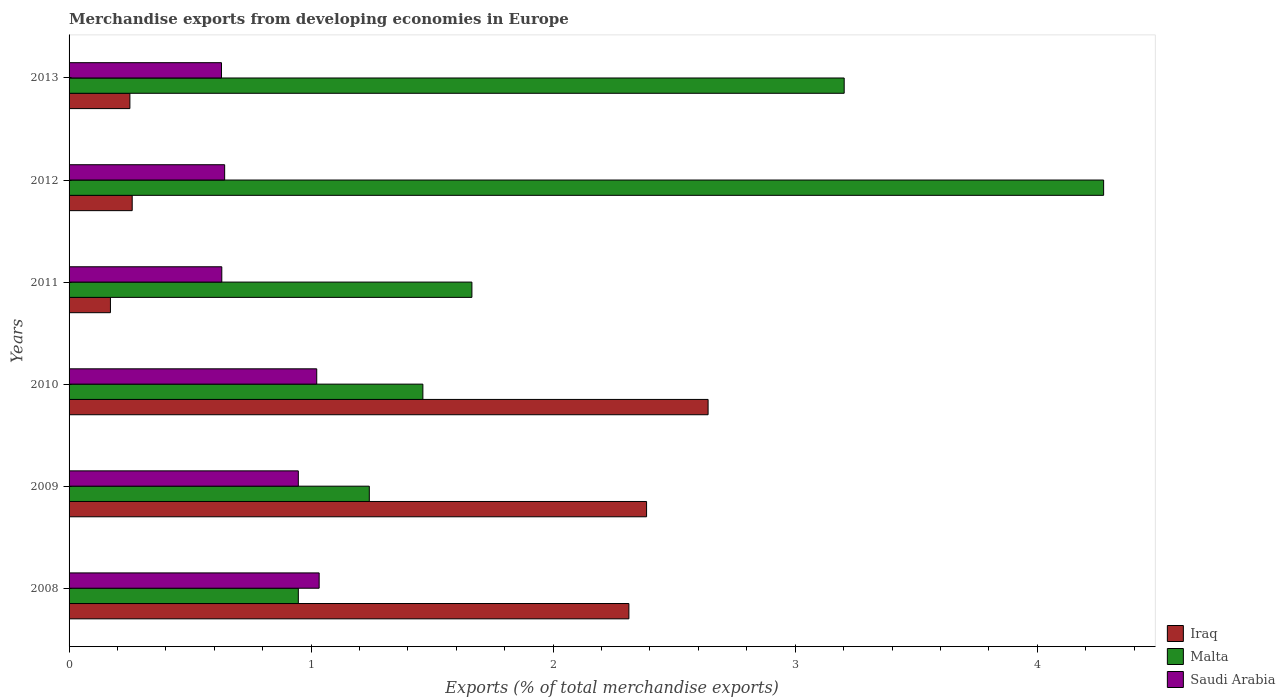How many bars are there on the 2nd tick from the top?
Offer a very short reply. 3. What is the percentage of total merchandise exports in Saudi Arabia in 2010?
Give a very brief answer. 1.02. Across all years, what is the maximum percentage of total merchandise exports in Saudi Arabia?
Your answer should be very brief. 1.03. Across all years, what is the minimum percentage of total merchandise exports in Malta?
Provide a short and direct response. 0.95. In which year was the percentage of total merchandise exports in Malta minimum?
Offer a very short reply. 2008. What is the total percentage of total merchandise exports in Iraq in the graph?
Ensure brevity in your answer.  8.02. What is the difference between the percentage of total merchandise exports in Saudi Arabia in 2010 and that in 2011?
Offer a very short reply. 0.39. What is the difference between the percentage of total merchandise exports in Saudi Arabia in 2010 and the percentage of total merchandise exports in Malta in 2009?
Your answer should be very brief. -0.22. What is the average percentage of total merchandise exports in Iraq per year?
Provide a short and direct response. 1.34. In the year 2009, what is the difference between the percentage of total merchandise exports in Saudi Arabia and percentage of total merchandise exports in Malta?
Ensure brevity in your answer.  -0.29. What is the ratio of the percentage of total merchandise exports in Malta in 2009 to that in 2012?
Give a very brief answer. 0.29. Is the percentage of total merchandise exports in Malta in 2008 less than that in 2011?
Keep it short and to the point. Yes. What is the difference between the highest and the second highest percentage of total merchandise exports in Malta?
Your answer should be very brief. 1.07. What is the difference between the highest and the lowest percentage of total merchandise exports in Saudi Arabia?
Ensure brevity in your answer.  0.4. Is the sum of the percentage of total merchandise exports in Malta in 2009 and 2012 greater than the maximum percentage of total merchandise exports in Saudi Arabia across all years?
Your response must be concise. Yes. What does the 2nd bar from the top in 2009 represents?
Give a very brief answer. Malta. What does the 2nd bar from the bottom in 2011 represents?
Offer a very short reply. Malta. What is the difference between two consecutive major ticks on the X-axis?
Give a very brief answer. 1. Are the values on the major ticks of X-axis written in scientific E-notation?
Offer a terse response. No. Where does the legend appear in the graph?
Offer a terse response. Bottom right. How many legend labels are there?
Keep it short and to the point. 3. What is the title of the graph?
Provide a succinct answer. Merchandise exports from developing economies in Europe. Does "Tonga" appear as one of the legend labels in the graph?
Make the answer very short. No. What is the label or title of the X-axis?
Ensure brevity in your answer.  Exports (% of total merchandise exports). What is the Exports (% of total merchandise exports) of Iraq in 2008?
Offer a terse response. 2.31. What is the Exports (% of total merchandise exports) of Malta in 2008?
Your answer should be very brief. 0.95. What is the Exports (% of total merchandise exports) in Saudi Arabia in 2008?
Your response must be concise. 1.03. What is the Exports (% of total merchandise exports) in Iraq in 2009?
Offer a very short reply. 2.39. What is the Exports (% of total merchandise exports) of Malta in 2009?
Make the answer very short. 1.24. What is the Exports (% of total merchandise exports) in Saudi Arabia in 2009?
Make the answer very short. 0.95. What is the Exports (% of total merchandise exports) of Iraq in 2010?
Provide a short and direct response. 2.64. What is the Exports (% of total merchandise exports) of Malta in 2010?
Offer a terse response. 1.46. What is the Exports (% of total merchandise exports) of Saudi Arabia in 2010?
Your answer should be compact. 1.02. What is the Exports (% of total merchandise exports) of Iraq in 2011?
Give a very brief answer. 0.17. What is the Exports (% of total merchandise exports) of Malta in 2011?
Provide a short and direct response. 1.66. What is the Exports (% of total merchandise exports) in Saudi Arabia in 2011?
Your answer should be very brief. 0.63. What is the Exports (% of total merchandise exports) of Iraq in 2012?
Provide a succinct answer. 0.26. What is the Exports (% of total merchandise exports) of Malta in 2012?
Ensure brevity in your answer.  4.27. What is the Exports (% of total merchandise exports) in Saudi Arabia in 2012?
Keep it short and to the point. 0.64. What is the Exports (% of total merchandise exports) of Iraq in 2013?
Ensure brevity in your answer.  0.25. What is the Exports (% of total merchandise exports) in Malta in 2013?
Keep it short and to the point. 3.2. What is the Exports (% of total merchandise exports) in Saudi Arabia in 2013?
Keep it short and to the point. 0.63. Across all years, what is the maximum Exports (% of total merchandise exports) of Iraq?
Your answer should be very brief. 2.64. Across all years, what is the maximum Exports (% of total merchandise exports) in Malta?
Offer a terse response. 4.27. Across all years, what is the maximum Exports (% of total merchandise exports) of Saudi Arabia?
Your answer should be compact. 1.03. Across all years, what is the minimum Exports (% of total merchandise exports) of Iraq?
Offer a terse response. 0.17. Across all years, what is the minimum Exports (% of total merchandise exports) of Malta?
Your response must be concise. 0.95. Across all years, what is the minimum Exports (% of total merchandise exports) in Saudi Arabia?
Offer a terse response. 0.63. What is the total Exports (% of total merchandise exports) in Iraq in the graph?
Keep it short and to the point. 8.02. What is the total Exports (% of total merchandise exports) of Malta in the graph?
Ensure brevity in your answer.  12.79. What is the total Exports (% of total merchandise exports) of Saudi Arabia in the graph?
Your answer should be compact. 4.91. What is the difference between the Exports (% of total merchandise exports) in Iraq in 2008 and that in 2009?
Your answer should be very brief. -0.07. What is the difference between the Exports (% of total merchandise exports) of Malta in 2008 and that in 2009?
Your answer should be very brief. -0.29. What is the difference between the Exports (% of total merchandise exports) of Saudi Arabia in 2008 and that in 2009?
Keep it short and to the point. 0.09. What is the difference between the Exports (% of total merchandise exports) in Iraq in 2008 and that in 2010?
Make the answer very short. -0.33. What is the difference between the Exports (% of total merchandise exports) in Malta in 2008 and that in 2010?
Keep it short and to the point. -0.51. What is the difference between the Exports (% of total merchandise exports) in Saudi Arabia in 2008 and that in 2010?
Offer a very short reply. 0.01. What is the difference between the Exports (% of total merchandise exports) of Iraq in 2008 and that in 2011?
Make the answer very short. 2.14. What is the difference between the Exports (% of total merchandise exports) in Malta in 2008 and that in 2011?
Give a very brief answer. -0.72. What is the difference between the Exports (% of total merchandise exports) in Saudi Arabia in 2008 and that in 2011?
Provide a short and direct response. 0.4. What is the difference between the Exports (% of total merchandise exports) of Iraq in 2008 and that in 2012?
Keep it short and to the point. 2.05. What is the difference between the Exports (% of total merchandise exports) of Malta in 2008 and that in 2012?
Your answer should be compact. -3.33. What is the difference between the Exports (% of total merchandise exports) in Saudi Arabia in 2008 and that in 2012?
Ensure brevity in your answer.  0.39. What is the difference between the Exports (% of total merchandise exports) of Iraq in 2008 and that in 2013?
Your answer should be compact. 2.06. What is the difference between the Exports (% of total merchandise exports) in Malta in 2008 and that in 2013?
Make the answer very short. -2.26. What is the difference between the Exports (% of total merchandise exports) of Saudi Arabia in 2008 and that in 2013?
Your answer should be very brief. 0.4. What is the difference between the Exports (% of total merchandise exports) of Iraq in 2009 and that in 2010?
Ensure brevity in your answer.  -0.25. What is the difference between the Exports (% of total merchandise exports) in Malta in 2009 and that in 2010?
Keep it short and to the point. -0.22. What is the difference between the Exports (% of total merchandise exports) in Saudi Arabia in 2009 and that in 2010?
Ensure brevity in your answer.  -0.08. What is the difference between the Exports (% of total merchandise exports) in Iraq in 2009 and that in 2011?
Make the answer very short. 2.22. What is the difference between the Exports (% of total merchandise exports) of Malta in 2009 and that in 2011?
Give a very brief answer. -0.42. What is the difference between the Exports (% of total merchandise exports) of Saudi Arabia in 2009 and that in 2011?
Offer a very short reply. 0.32. What is the difference between the Exports (% of total merchandise exports) in Iraq in 2009 and that in 2012?
Your answer should be compact. 2.13. What is the difference between the Exports (% of total merchandise exports) in Malta in 2009 and that in 2012?
Ensure brevity in your answer.  -3.03. What is the difference between the Exports (% of total merchandise exports) of Saudi Arabia in 2009 and that in 2012?
Your answer should be very brief. 0.3. What is the difference between the Exports (% of total merchandise exports) of Iraq in 2009 and that in 2013?
Keep it short and to the point. 2.13. What is the difference between the Exports (% of total merchandise exports) in Malta in 2009 and that in 2013?
Your answer should be compact. -1.96. What is the difference between the Exports (% of total merchandise exports) in Saudi Arabia in 2009 and that in 2013?
Make the answer very short. 0.32. What is the difference between the Exports (% of total merchandise exports) of Iraq in 2010 and that in 2011?
Your answer should be compact. 2.47. What is the difference between the Exports (% of total merchandise exports) in Malta in 2010 and that in 2011?
Offer a very short reply. -0.2. What is the difference between the Exports (% of total merchandise exports) of Saudi Arabia in 2010 and that in 2011?
Give a very brief answer. 0.39. What is the difference between the Exports (% of total merchandise exports) in Iraq in 2010 and that in 2012?
Provide a short and direct response. 2.38. What is the difference between the Exports (% of total merchandise exports) in Malta in 2010 and that in 2012?
Your answer should be very brief. -2.81. What is the difference between the Exports (% of total merchandise exports) of Saudi Arabia in 2010 and that in 2012?
Your answer should be compact. 0.38. What is the difference between the Exports (% of total merchandise exports) in Iraq in 2010 and that in 2013?
Make the answer very short. 2.39. What is the difference between the Exports (% of total merchandise exports) of Malta in 2010 and that in 2013?
Your response must be concise. -1.74. What is the difference between the Exports (% of total merchandise exports) in Saudi Arabia in 2010 and that in 2013?
Ensure brevity in your answer.  0.39. What is the difference between the Exports (% of total merchandise exports) in Iraq in 2011 and that in 2012?
Make the answer very short. -0.09. What is the difference between the Exports (% of total merchandise exports) in Malta in 2011 and that in 2012?
Your response must be concise. -2.61. What is the difference between the Exports (% of total merchandise exports) in Saudi Arabia in 2011 and that in 2012?
Your response must be concise. -0.01. What is the difference between the Exports (% of total merchandise exports) in Iraq in 2011 and that in 2013?
Your answer should be very brief. -0.08. What is the difference between the Exports (% of total merchandise exports) in Malta in 2011 and that in 2013?
Provide a succinct answer. -1.54. What is the difference between the Exports (% of total merchandise exports) of Saudi Arabia in 2011 and that in 2013?
Offer a terse response. 0. What is the difference between the Exports (% of total merchandise exports) in Iraq in 2012 and that in 2013?
Offer a very short reply. 0.01. What is the difference between the Exports (% of total merchandise exports) in Malta in 2012 and that in 2013?
Your answer should be very brief. 1.07. What is the difference between the Exports (% of total merchandise exports) in Saudi Arabia in 2012 and that in 2013?
Make the answer very short. 0.01. What is the difference between the Exports (% of total merchandise exports) of Iraq in 2008 and the Exports (% of total merchandise exports) of Malta in 2009?
Your answer should be very brief. 1.07. What is the difference between the Exports (% of total merchandise exports) in Iraq in 2008 and the Exports (% of total merchandise exports) in Saudi Arabia in 2009?
Provide a short and direct response. 1.37. What is the difference between the Exports (% of total merchandise exports) of Iraq in 2008 and the Exports (% of total merchandise exports) of Malta in 2010?
Offer a very short reply. 0.85. What is the difference between the Exports (% of total merchandise exports) in Iraq in 2008 and the Exports (% of total merchandise exports) in Saudi Arabia in 2010?
Your response must be concise. 1.29. What is the difference between the Exports (% of total merchandise exports) of Malta in 2008 and the Exports (% of total merchandise exports) of Saudi Arabia in 2010?
Give a very brief answer. -0.08. What is the difference between the Exports (% of total merchandise exports) of Iraq in 2008 and the Exports (% of total merchandise exports) of Malta in 2011?
Your response must be concise. 0.65. What is the difference between the Exports (% of total merchandise exports) in Iraq in 2008 and the Exports (% of total merchandise exports) in Saudi Arabia in 2011?
Offer a terse response. 1.68. What is the difference between the Exports (% of total merchandise exports) of Malta in 2008 and the Exports (% of total merchandise exports) of Saudi Arabia in 2011?
Offer a very short reply. 0.32. What is the difference between the Exports (% of total merchandise exports) of Iraq in 2008 and the Exports (% of total merchandise exports) of Malta in 2012?
Ensure brevity in your answer.  -1.96. What is the difference between the Exports (% of total merchandise exports) of Iraq in 2008 and the Exports (% of total merchandise exports) of Saudi Arabia in 2012?
Your response must be concise. 1.67. What is the difference between the Exports (% of total merchandise exports) in Malta in 2008 and the Exports (% of total merchandise exports) in Saudi Arabia in 2012?
Offer a very short reply. 0.3. What is the difference between the Exports (% of total merchandise exports) in Iraq in 2008 and the Exports (% of total merchandise exports) in Malta in 2013?
Your response must be concise. -0.89. What is the difference between the Exports (% of total merchandise exports) of Iraq in 2008 and the Exports (% of total merchandise exports) of Saudi Arabia in 2013?
Your answer should be very brief. 1.68. What is the difference between the Exports (% of total merchandise exports) of Malta in 2008 and the Exports (% of total merchandise exports) of Saudi Arabia in 2013?
Your answer should be compact. 0.32. What is the difference between the Exports (% of total merchandise exports) in Iraq in 2009 and the Exports (% of total merchandise exports) in Malta in 2010?
Ensure brevity in your answer.  0.92. What is the difference between the Exports (% of total merchandise exports) in Iraq in 2009 and the Exports (% of total merchandise exports) in Saudi Arabia in 2010?
Provide a short and direct response. 1.36. What is the difference between the Exports (% of total merchandise exports) of Malta in 2009 and the Exports (% of total merchandise exports) of Saudi Arabia in 2010?
Offer a very short reply. 0.22. What is the difference between the Exports (% of total merchandise exports) in Iraq in 2009 and the Exports (% of total merchandise exports) in Malta in 2011?
Give a very brief answer. 0.72. What is the difference between the Exports (% of total merchandise exports) of Iraq in 2009 and the Exports (% of total merchandise exports) of Saudi Arabia in 2011?
Provide a succinct answer. 1.75. What is the difference between the Exports (% of total merchandise exports) in Malta in 2009 and the Exports (% of total merchandise exports) in Saudi Arabia in 2011?
Offer a terse response. 0.61. What is the difference between the Exports (% of total merchandise exports) of Iraq in 2009 and the Exports (% of total merchandise exports) of Malta in 2012?
Your answer should be very brief. -1.89. What is the difference between the Exports (% of total merchandise exports) of Iraq in 2009 and the Exports (% of total merchandise exports) of Saudi Arabia in 2012?
Your answer should be very brief. 1.74. What is the difference between the Exports (% of total merchandise exports) in Malta in 2009 and the Exports (% of total merchandise exports) in Saudi Arabia in 2012?
Keep it short and to the point. 0.6. What is the difference between the Exports (% of total merchandise exports) of Iraq in 2009 and the Exports (% of total merchandise exports) of Malta in 2013?
Make the answer very short. -0.82. What is the difference between the Exports (% of total merchandise exports) of Iraq in 2009 and the Exports (% of total merchandise exports) of Saudi Arabia in 2013?
Provide a succinct answer. 1.76. What is the difference between the Exports (% of total merchandise exports) in Malta in 2009 and the Exports (% of total merchandise exports) in Saudi Arabia in 2013?
Give a very brief answer. 0.61. What is the difference between the Exports (% of total merchandise exports) in Iraq in 2010 and the Exports (% of total merchandise exports) in Malta in 2011?
Ensure brevity in your answer.  0.98. What is the difference between the Exports (% of total merchandise exports) of Iraq in 2010 and the Exports (% of total merchandise exports) of Saudi Arabia in 2011?
Provide a succinct answer. 2.01. What is the difference between the Exports (% of total merchandise exports) of Malta in 2010 and the Exports (% of total merchandise exports) of Saudi Arabia in 2011?
Your response must be concise. 0.83. What is the difference between the Exports (% of total merchandise exports) in Iraq in 2010 and the Exports (% of total merchandise exports) in Malta in 2012?
Your response must be concise. -1.63. What is the difference between the Exports (% of total merchandise exports) in Iraq in 2010 and the Exports (% of total merchandise exports) in Saudi Arabia in 2012?
Make the answer very short. 2. What is the difference between the Exports (% of total merchandise exports) in Malta in 2010 and the Exports (% of total merchandise exports) in Saudi Arabia in 2012?
Your answer should be very brief. 0.82. What is the difference between the Exports (% of total merchandise exports) of Iraq in 2010 and the Exports (% of total merchandise exports) of Malta in 2013?
Your answer should be compact. -0.56. What is the difference between the Exports (% of total merchandise exports) of Iraq in 2010 and the Exports (% of total merchandise exports) of Saudi Arabia in 2013?
Provide a succinct answer. 2.01. What is the difference between the Exports (% of total merchandise exports) in Malta in 2010 and the Exports (% of total merchandise exports) in Saudi Arabia in 2013?
Give a very brief answer. 0.83. What is the difference between the Exports (% of total merchandise exports) in Iraq in 2011 and the Exports (% of total merchandise exports) in Malta in 2012?
Offer a very short reply. -4.1. What is the difference between the Exports (% of total merchandise exports) in Iraq in 2011 and the Exports (% of total merchandise exports) in Saudi Arabia in 2012?
Offer a very short reply. -0.47. What is the difference between the Exports (% of total merchandise exports) of Malta in 2011 and the Exports (% of total merchandise exports) of Saudi Arabia in 2012?
Offer a terse response. 1.02. What is the difference between the Exports (% of total merchandise exports) in Iraq in 2011 and the Exports (% of total merchandise exports) in Malta in 2013?
Provide a short and direct response. -3.03. What is the difference between the Exports (% of total merchandise exports) in Iraq in 2011 and the Exports (% of total merchandise exports) in Saudi Arabia in 2013?
Your answer should be very brief. -0.46. What is the difference between the Exports (% of total merchandise exports) of Malta in 2011 and the Exports (% of total merchandise exports) of Saudi Arabia in 2013?
Provide a succinct answer. 1.03. What is the difference between the Exports (% of total merchandise exports) in Iraq in 2012 and the Exports (% of total merchandise exports) in Malta in 2013?
Your answer should be very brief. -2.94. What is the difference between the Exports (% of total merchandise exports) of Iraq in 2012 and the Exports (% of total merchandise exports) of Saudi Arabia in 2013?
Provide a short and direct response. -0.37. What is the difference between the Exports (% of total merchandise exports) in Malta in 2012 and the Exports (% of total merchandise exports) in Saudi Arabia in 2013?
Your answer should be very brief. 3.64. What is the average Exports (% of total merchandise exports) of Iraq per year?
Your answer should be very brief. 1.34. What is the average Exports (% of total merchandise exports) in Malta per year?
Offer a terse response. 2.13. What is the average Exports (% of total merchandise exports) in Saudi Arabia per year?
Keep it short and to the point. 0.82. In the year 2008, what is the difference between the Exports (% of total merchandise exports) of Iraq and Exports (% of total merchandise exports) of Malta?
Your answer should be very brief. 1.37. In the year 2008, what is the difference between the Exports (% of total merchandise exports) of Iraq and Exports (% of total merchandise exports) of Saudi Arabia?
Keep it short and to the point. 1.28. In the year 2008, what is the difference between the Exports (% of total merchandise exports) in Malta and Exports (% of total merchandise exports) in Saudi Arabia?
Offer a terse response. -0.09. In the year 2009, what is the difference between the Exports (% of total merchandise exports) in Iraq and Exports (% of total merchandise exports) in Malta?
Make the answer very short. 1.15. In the year 2009, what is the difference between the Exports (% of total merchandise exports) in Iraq and Exports (% of total merchandise exports) in Saudi Arabia?
Your answer should be very brief. 1.44. In the year 2009, what is the difference between the Exports (% of total merchandise exports) of Malta and Exports (% of total merchandise exports) of Saudi Arabia?
Make the answer very short. 0.29. In the year 2010, what is the difference between the Exports (% of total merchandise exports) in Iraq and Exports (% of total merchandise exports) in Malta?
Your answer should be very brief. 1.18. In the year 2010, what is the difference between the Exports (% of total merchandise exports) of Iraq and Exports (% of total merchandise exports) of Saudi Arabia?
Make the answer very short. 1.62. In the year 2010, what is the difference between the Exports (% of total merchandise exports) of Malta and Exports (% of total merchandise exports) of Saudi Arabia?
Your response must be concise. 0.44. In the year 2011, what is the difference between the Exports (% of total merchandise exports) in Iraq and Exports (% of total merchandise exports) in Malta?
Your response must be concise. -1.49. In the year 2011, what is the difference between the Exports (% of total merchandise exports) in Iraq and Exports (% of total merchandise exports) in Saudi Arabia?
Provide a succinct answer. -0.46. In the year 2011, what is the difference between the Exports (% of total merchandise exports) of Malta and Exports (% of total merchandise exports) of Saudi Arabia?
Keep it short and to the point. 1.03. In the year 2012, what is the difference between the Exports (% of total merchandise exports) in Iraq and Exports (% of total merchandise exports) in Malta?
Provide a short and direct response. -4.01. In the year 2012, what is the difference between the Exports (% of total merchandise exports) of Iraq and Exports (% of total merchandise exports) of Saudi Arabia?
Keep it short and to the point. -0.38. In the year 2012, what is the difference between the Exports (% of total merchandise exports) of Malta and Exports (% of total merchandise exports) of Saudi Arabia?
Give a very brief answer. 3.63. In the year 2013, what is the difference between the Exports (% of total merchandise exports) of Iraq and Exports (% of total merchandise exports) of Malta?
Give a very brief answer. -2.95. In the year 2013, what is the difference between the Exports (% of total merchandise exports) in Iraq and Exports (% of total merchandise exports) in Saudi Arabia?
Your response must be concise. -0.38. In the year 2013, what is the difference between the Exports (% of total merchandise exports) of Malta and Exports (% of total merchandise exports) of Saudi Arabia?
Your answer should be very brief. 2.57. What is the ratio of the Exports (% of total merchandise exports) in Iraq in 2008 to that in 2009?
Provide a succinct answer. 0.97. What is the ratio of the Exports (% of total merchandise exports) of Malta in 2008 to that in 2009?
Give a very brief answer. 0.76. What is the ratio of the Exports (% of total merchandise exports) in Iraq in 2008 to that in 2010?
Your answer should be compact. 0.88. What is the ratio of the Exports (% of total merchandise exports) in Malta in 2008 to that in 2010?
Keep it short and to the point. 0.65. What is the ratio of the Exports (% of total merchandise exports) of Saudi Arabia in 2008 to that in 2010?
Keep it short and to the point. 1.01. What is the ratio of the Exports (% of total merchandise exports) in Iraq in 2008 to that in 2011?
Your response must be concise. 13.54. What is the ratio of the Exports (% of total merchandise exports) in Malta in 2008 to that in 2011?
Your answer should be very brief. 0.57. What is the ratio of the Exports (% of total merchandise exports) in Saudi Arabia in 2008 to that in 2011?
Offer a terse response. 1.64. What is the ratio of the Exports (% of total merchandise exports) of Iraq in 2008 to that in 2012?
Offer a terse response. 8.87. What is the ratio of the Exports (% of total merchandise exports) of Malta in 2008 to that in 2012?
Give a very brief answer. 0.22. What is the ratio of the Exports (% of total merchandise exports) in Saudi Arabia in 2008 to that in 2012?
Provide a succinct answer. 1.61. What is the ratio of the Exports (% of total merchandise exports) in Iraq in 2008 to that in 2013?
Make the answer very short. 9.21. What is the ratio of the Exports (% of total merchandise exports) of Malta in 2008 to that in 2013?
Ensure brevity in your answer.  0.3. What is the ratio of the Exports (% of total merchandise exports) in Saudi Arabia in 2008 to that in 2013?
Make the answer very short. 1.64. What is the ratio of the Exports (% of total merchandise exports) of Iraq in 2009 to that in 2010?
Provide a short and direct response. 0.9. What is the ratio of the Exports (% of total merchandise exports) in Malta in 2009 to that in 2010?
Ensure brevity in your answer.  0.85. What is the ratio of the Exports (% of total merchandise exports) of Saudi Arabia in 2009 to that in 2010?
Ensure brevity in your answer.  0.93. What is the ratio of the Exports (% of total merchandise exports) in Iraq in 2009 to that in 2011?
Provide a short and direct response. 13.96. What is the ratio of the Exports (% of total merchandise exports) in Malta in 2009 to that in 2011?
Your response must be concise. 0.75. What is the ratio of the Exports (% of total merchandise exports) in Saudi Arabia in 2009 to that in 2011?
Your response must be concise. 1.5. What is the ratio of the Exports (% of total merchandise exports) of Iraq in 2009 to that in 2012?
Provide a short and direct response. 9.15. What is the ratio of the Exports (% of total merchandise exports) of Malta in 2009 to that in 2012?
Your response must be concise. 0.29. What is the ratio of the Exports (% of total merchandise exports) in Saudi Arabia in 2009 to that in 2012?
Provide a short and direct response. 1.47. What is the ratio of the Exports (% of total merchandise exports) of Iraq in 2009 to that in 2013?
Your answer should be very brief. 9.5. What is the ratio of the Exports (% of total merchandise exports) in Malta in 2009 to that in 2013?
Your answer should be compact. 0.39. What is the ratio of the Exports (% of total merchandise exports) of Saudi Arabia in 2009 to that in 2013?
Keep it short and to the point. 1.5. What is the ratio of the Exports (% of total merchandise exports) in Iraq in 2010 to that in 2011?
Keep it short and to the point. 15.45. What is the ratio of the Exports (% of total merchandise exports) in Malta in 2010 to that in 2011?
Keep it short and to the point. 0.88. What is the ratio of the Exports (% of total merchandise exports) of Saudi Arabia in 2010 to that in 2011?
Make the answer very short. 1.62. What is the ratio of the Exports (% of total merchandise exports) in Iraq in 2010 to that in 2012?
Ensure brevity in your answer.  10.12. What is the ratio of the Exports (% of total merchandise exports) of Malta in 2010 to that in 2012?
Make the answer very short. 0.34. What is the ratio of the Exports (% of total merchandise exports) in Saudi Arabia in 2010 to that in 2012?
Ensure brevity in your answer.  1.59. What is the ratio of the Exports (% of total merchandise exports) of Iraq in 2010 to that in 2013?
Ensure brevity in your answer.  10.51. What is the ratio of the Exports (% of total merchandise exports) of Malta in 2010 to that in 2013?
Offer a terse response. 0.46. What is the ratio of the Exports (% of total merchandise exports) in Saudi Arabia in 2010 to that in 2013?
Your answer should be very brief. 1.62. What is the ratio of the Exports (% of total merchandise exports) in Iraq in 2011 to that in 2012?
Keep it short and to the point. 0.66. What is the ratio of the Exports (% of total merchandise exports) of Malta in 2011 to that in 2012?
Keep it short and to the point. 0.39. What is the ratio of the Exports (% of total merchandise exports) in Saudi Arabia in 2011 to that in 2012?
Your answer should be compact. 0.98. What is the ratio of the Exports (% of total merchandise exports) of Iraq in 2011 to that in 2013?
Keep it short and to the point. 0.68. What is the ratio of the Exports (% of total merchandise exports) of Malta in 2011 to that in 2013?
Your answer should be very brief. 0.52. What is the ratio of the Exports (% of total merchandise exports) in Saudi Arabia in 2011 to that in 2013?
Give a very brief answer. 1. What is the ratio of the Exports (% of total merchandise exports) in Iraq in 2012 to that in 2013?
Provide a short and direct response. 1.04. What is the ratio of the Exports (% of total merchandise exports) of Malta in 2012 to that in 2013?
Keep it short and to the point. 1.33. What is the ratio of the Exports (% of total merchandise exports) in Saudi Arabia in 2012 to that in 2013?
Ensure brevity in your answer.  1.02. What is the difference between the highest and the second highest Exports (% of total merchandise exports) of Iraq?
Provide a short and direct response. 0.25. What is the difference between the highest and the second highest Exports (% of total merchandise exports) in Malta?
Make the answer very short. 1.07. What is the difference between the highest and the second highest Exports (% of total merchandise exports) of Saudi Arabia?
Give a very brief answer. 0.01. What is the difference between the highest and the lowest Exports (% of total merchandise exports) of Iraq?
Provide a short and direct response. 2.47. What is the difference between the highest and the lowest Exports (% of total merchandise exports) of Malta?
Keep it short and to the point. 3.33. What is the difference between the highest and the lowest Exports (% of total merchandise exports) in Saudi Arabia?
Provide a short and direct response. 0.4. 